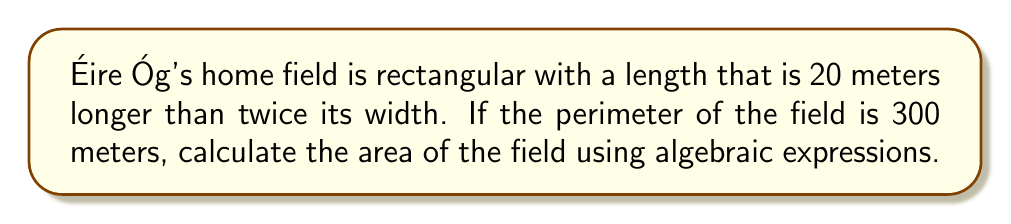Can you answer this question? Let's approach this step-by-step:

1) Let the width of the field be $w$ meters.

2) Given that the length is 20 meters longer than twice the width, we can express the length as:
   $l = 2w + 20$

3) The perimeter of a rectangle is given by the formula $P = 2l + 2w$. We know the perimeter is 300 meters, so:
   $300 = 2(2w + 20) + 2w$

4) Simplify the equation:
   $300 = 4w + 40 + 2w$
   $300 = 6w + 40$

5) Solve for $w$:
   $260 = 6w$
   $w = \frac{260}{6} \approx 43.33$ meters

6) Now that we know the width, we can calculate the length:
   $l = 2(43.33) + 20 \approx 106.67$ meters

7) The area of a rectangle is given by $A = lw$. So:
   $A = 106.67 \times 43.33 \approx 4,622.22$ square meters

Therefore, the area of Éire Óg's home field is approximately 4,622.22 square meters.
Answer: $4,622.22 \text{ m}^2$ 